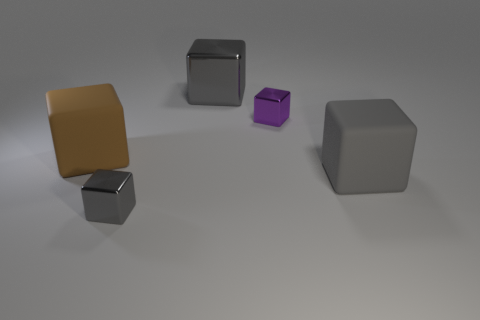What is the gray object behind the tiny purple cube made of?
Provide a succinct answer. Metal. Does the big gray matte thing have the same shape as the tiny shiny thing that is on the left side of the purple shiny block?
Offer a terse response. Yes. What is the material of the object that is both on the left side of the small purple cube and in front of the brown rubber block?
Ensure brevity in your answer.  Metal. There is another matte block that is the same size as the gray rubber block; what is its color?
Your answer should be compact. Brown. Is the big brown thing made of the same material as the big gray object that is in front of the brown cube?
Make the answer very short. Yes. What number of other objects are there of the same size as the purple metallic block?
Keep it short and to the point. 1. Is there a gray metallic cube to the right of the rubber block that is right of the large gray thing on the left side of the big gray rubber thing?
Provide a succinct answer. No. How big is the brown object?
Give a very brief answer. Large. There is a gray shiny thing in front of the purple metal block; what is its size?
Keep it short and to the point. Small. There is a shiny thing that is in front of the brown matte block; is it the same size as the big gray metal thing?
Offer a very short reply. No. 